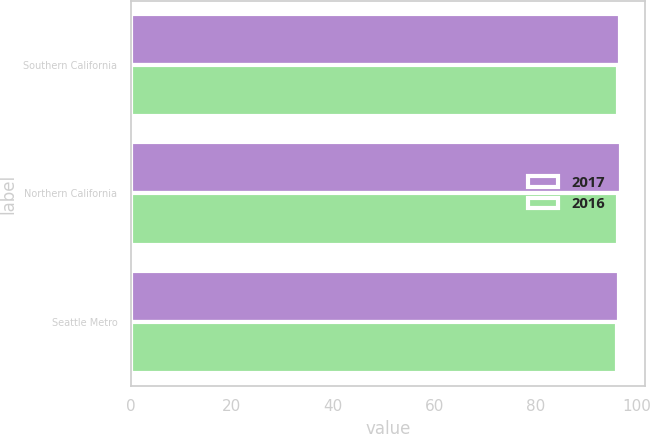Convert chart to OTSL. <chart><loc_0><loc_0><loc_500><loc_500><stacked_bar_chart><ecel><fcel>Southern California<fcel>Northern California<fcel>Seattle Metro<nl><fcel>2017<fcel>96.6<fcel>96.8<fcel>96.4<nl><fcel>2016<fcel>96.3<fcel>96.3<fcel>96.1<nl></chart> 